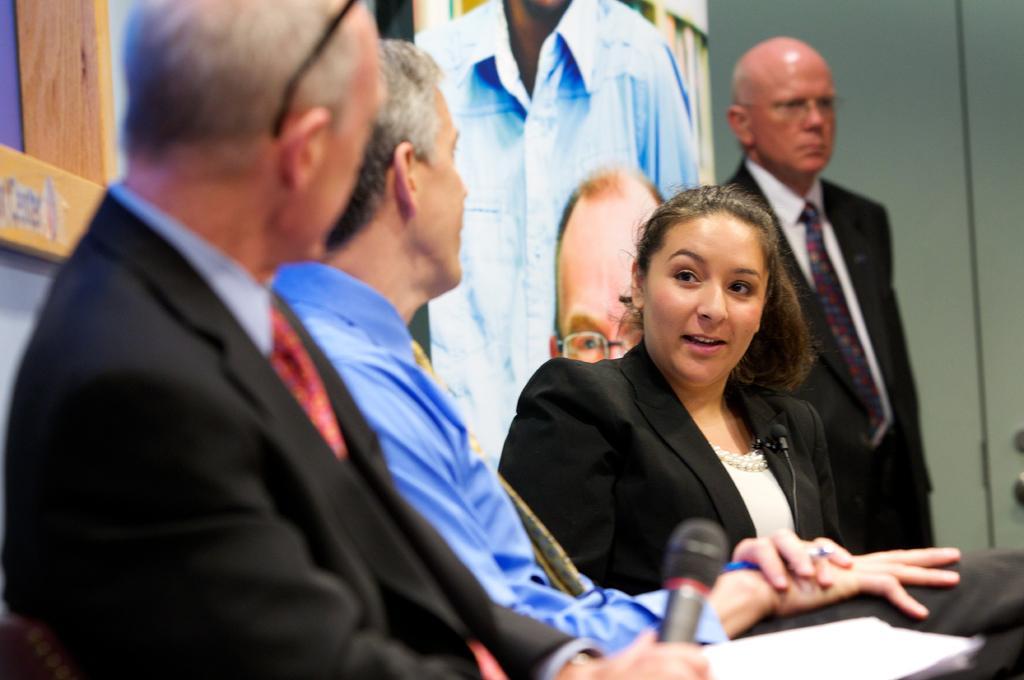Can you describe this image briefly? In the middle of the image three persons are sitting and he is holding a microphone and paper. Behind them there is wall and screen. On the right side of the image a person is standing. Behind him there is wall. 